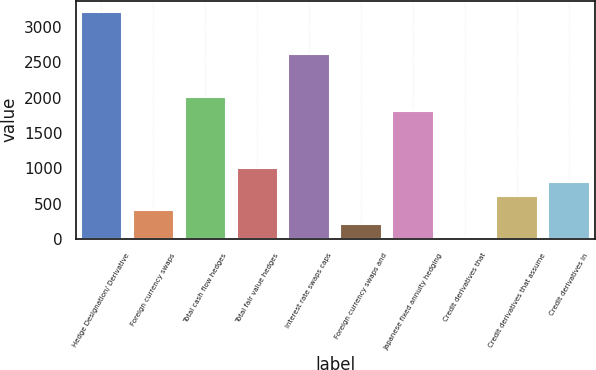Convert chart to OTSL. <chart><loc_0><loc_0><loc_500><loc_500><bar_chart><fcel>Hedge Designation/ Derivative<fcel>Foreign currency swaps<fcel>Total cash flow hedges<fcel>Total fair value hedges<fcel>Interest rate swaps caps<fcel>Foreign currency swaps and<fcel>Japanese fixed annuity hedging<fcel>Credit derivatives that<fcel>Credit derivatives that assume<fcel>Credit derivatives in<nl><fcel>3214.4<fcel>408.8<fcel>2012<fcel>1010<fcel>2613.2<fcel>208.4<fcel>1811.6<fcel>8<fcel>609.2<fcel>809.6<nl></chart> 